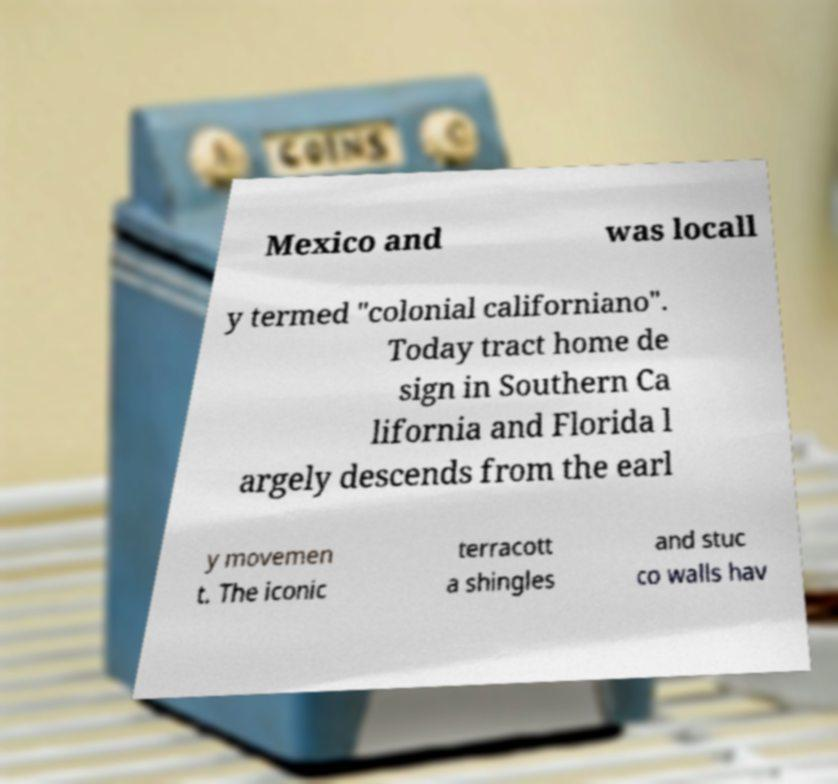Please identify and transcribe the text found in this image. Mexico and was locall y termed "colonial californiano". Today tract home de sign in Southern Ca lifornia and Florida l argely descends from the earl y movemen t. The iconic terracott a shingles and stuc co walls hav 